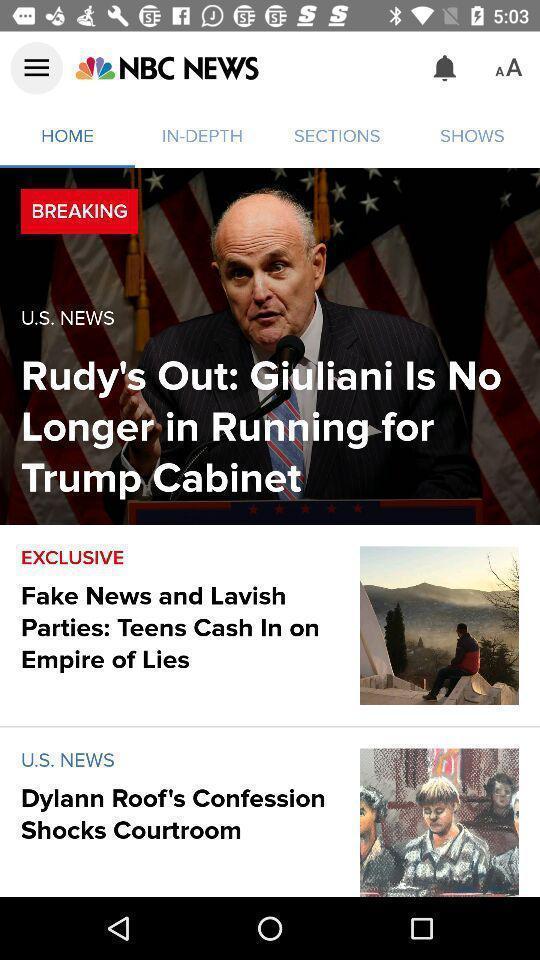Describe the visual elements of this screenshot. Window displaying list of news articles. 